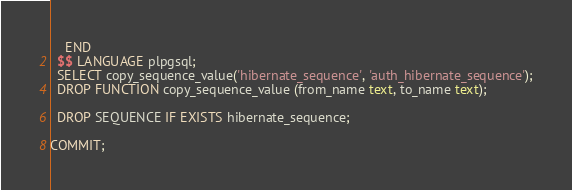Convert code to text. <code><loc_0><loc_0><loc_500><loc_500><_SQL_>    END
  $$ LANGUAGE plpgsql;
  SELECT copy_sequence_value('hibernate_sequence', 'auth_hibernate_sequence');
  DROP FUNCTION copy_sequence_value (from_name text, to_name text);

  DROP SEQUENCE IF EXISTS hibernate_sequence;

COMMIT;
</code> 